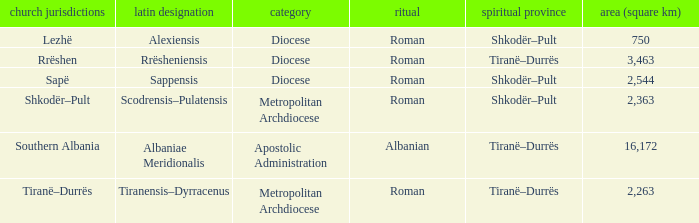What Ecclesiastical Province has a type diocese and a latin name alexiensis? Shkodër–Pult. 